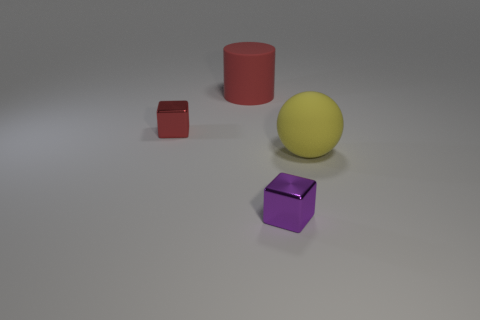Add 4 large green shiny objects. How many objects exist? 8 Subtract all purple blocks. How many blocks are left? 1 Subtract all balls. How many objects are left? 3 Subtract all blue blocks. How many green balls are left? 0 Subtract all tiny red rubber balls. Subtract all big yellow things. How many objects are left? 3 Add 1 shiny things. How many shiny things are left? 3 Add 1 yellow matte balls. How many yellow matte balls exist? 2 Subtract 0 green balls. How many objects are left? 4 Subtract 1 cylinders. How many cylinders are left? 0 Subtract all purple spheres. Subtract all gray blocks. How many spheres are left? 1 